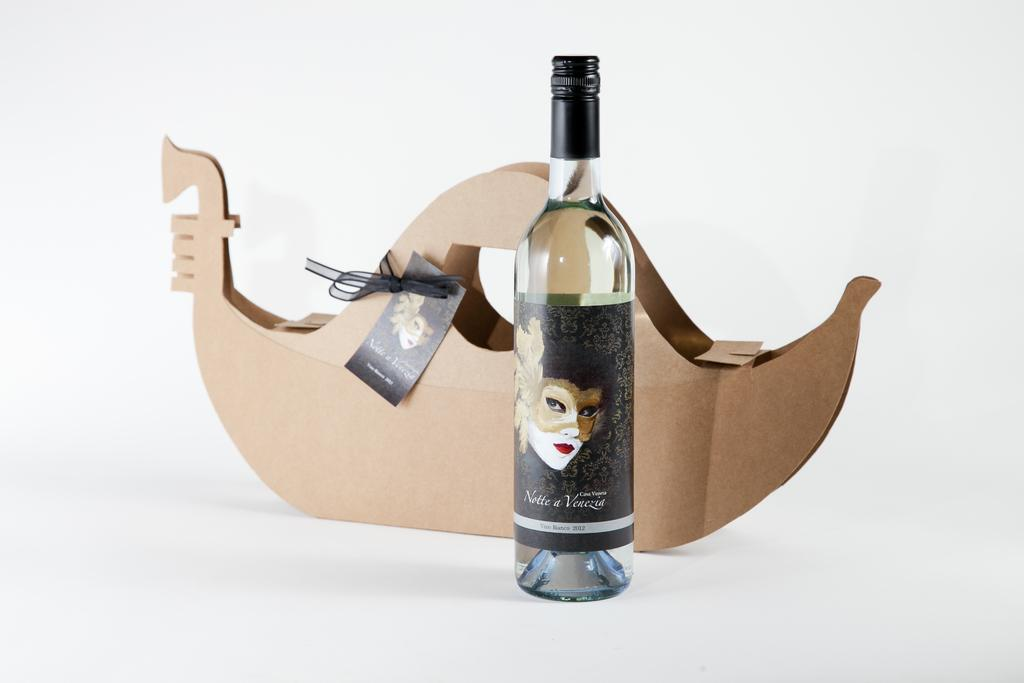Provide a one-sentence caption for the provided image. a wine bottle with the year 2012 on it. 